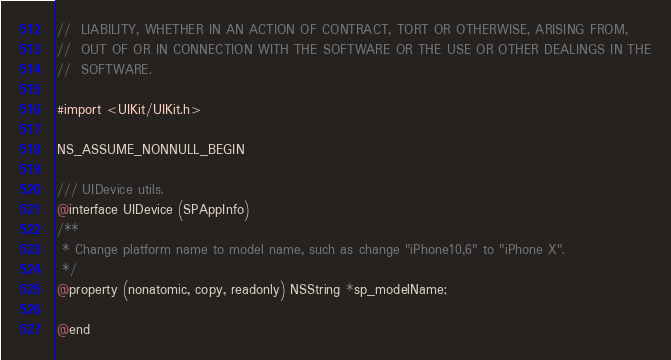Convert code to text. <code><loc_0><loc_0><loc_500><loc_500><_C_>//  LIABILITY, WHETHER IN AN ACTION OF CONTRACT, TORT OR OTHERWISE, ARISING FROM,
//  OUT OF OR IN CONNECTION WITH THE SOFTWARE OR THE USE OR OTHER DEALINGS IN THE
//  SOFTWARE.

#import <UIKit/UIKit.h>

NS_ASSUME_NONNULL_BEGIN

/// UIDevice utils.
@interface UIDevice (SPAppInfo)
/**
 * Change platform name to model name, such as change "iPhone10,6" to "iPhone X".
 */
@property (nonatomic, copy, readonly) NSString *sp_modelName;

@end
</code> 